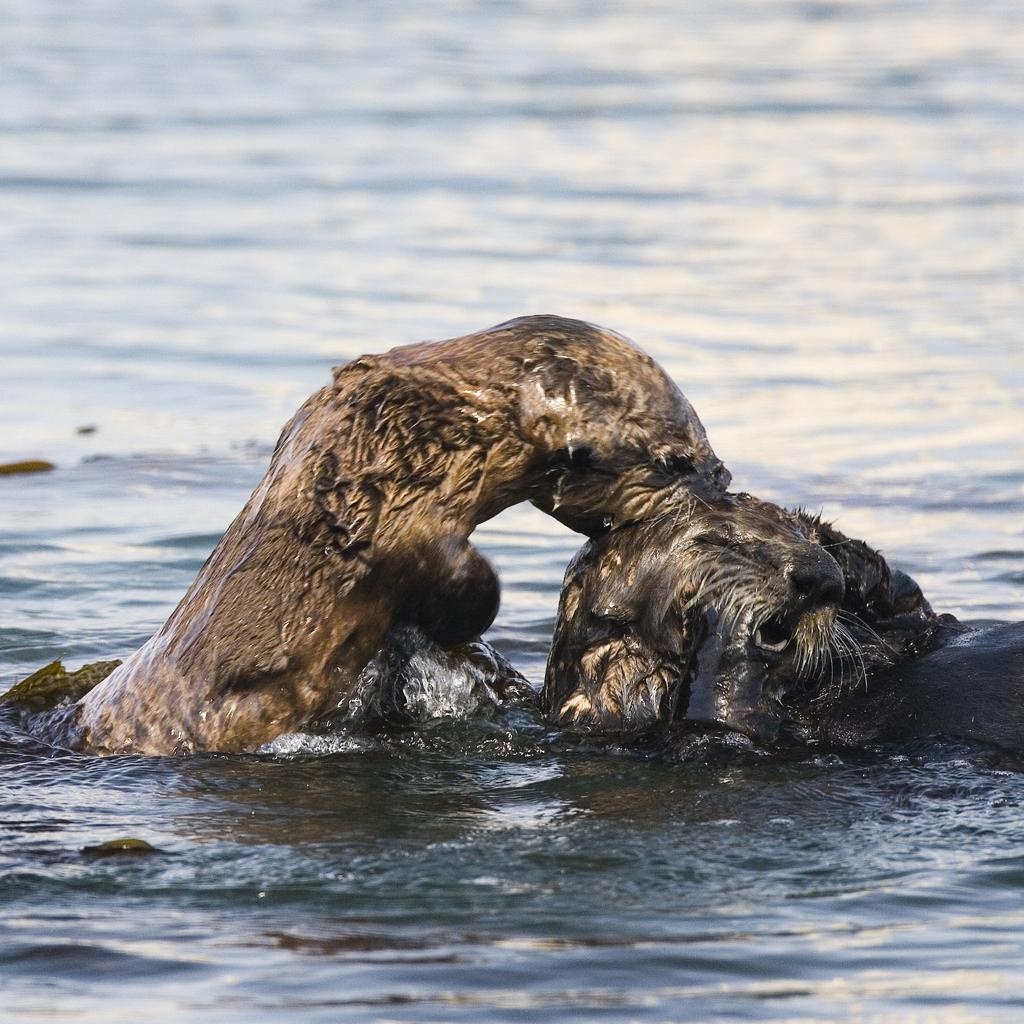What is present in the front of the image? There is water in the front of the image. What can be seen in the center of the image? There are aquatic animals in the center of the image. How many horses are present in the image? There are no horses present in the image; it features water and aquatic animals. What time of day is depicted in the image? The time of day cannot be determined from the image, as it only shows water and aquatic animals. 